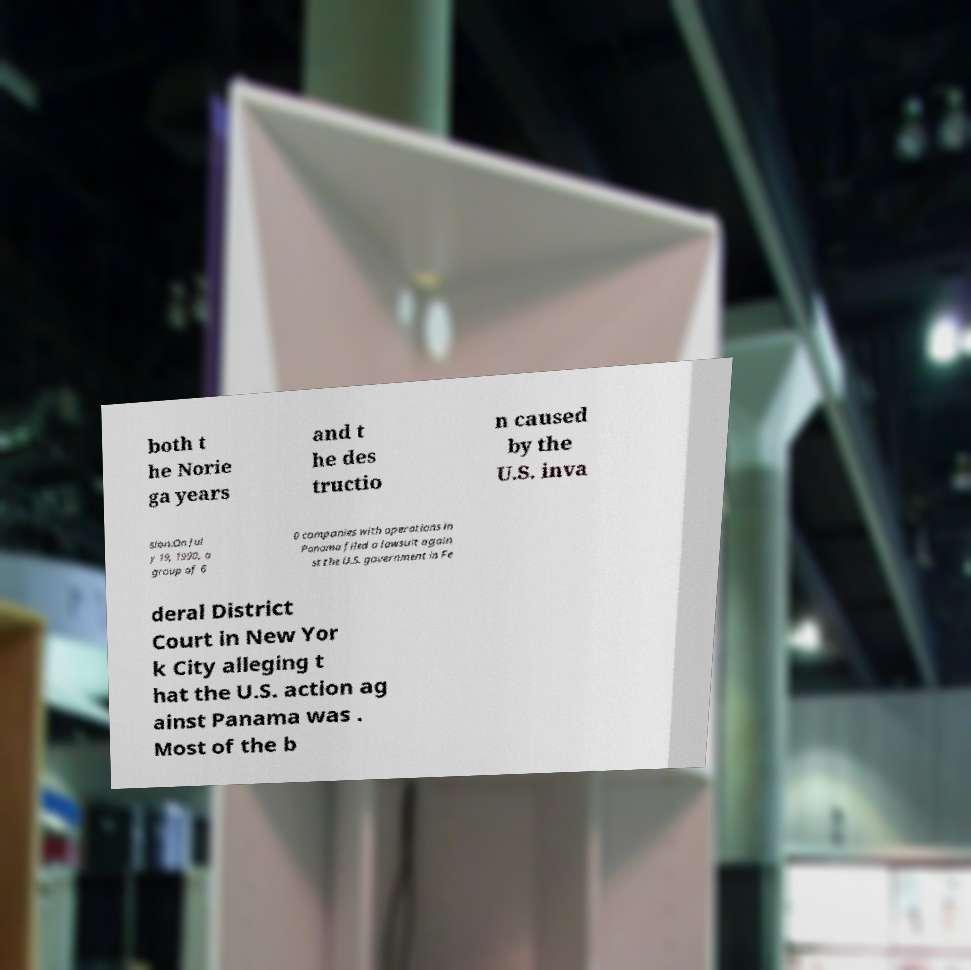I need the written content from this picture converted into text. Can you do that? both t he Norie ga years and t he des tructio n caused by the U.S. inva sion.On Jul y 19, 1990, a group of 6 0 companies with operations in Panama filed a lawsuit again st the U.S. government in Fe deral District Court in New Yor k City alleging t hat the U.S. action ag ainst Panama was . Most of the b 